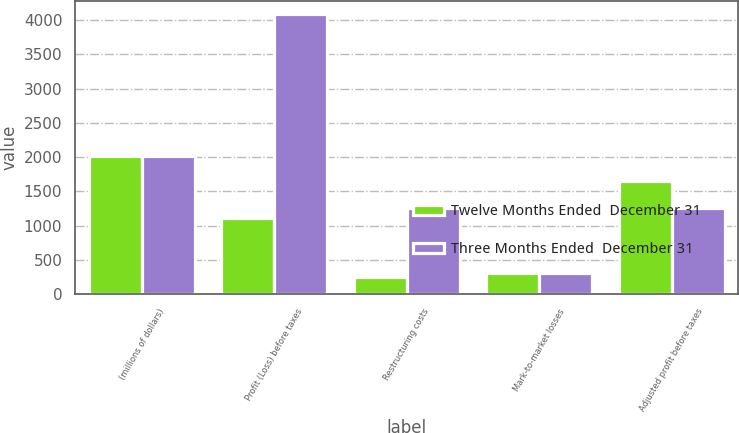Convert chart to OTSL. <chart><loc_0><loc_0><loc_500><loc_500><stacked_bar_chart><ecel><fcel>(millions of dollars)<fcel>Profit (Loss) before taxes<fcel>Restructuring costs<fcel>Mark-to-market losses<fcel>Adjusted profit before taxes<nl><fcel>Twelve Months Ended  December 31<fcel>2017<fcel>1111<fcel>245<fcel>301<fcel>1657<nl><fcel>Three Months Ended  December 31<fcel>2017<fcel>4082<fcel>1256<fcel>301<fcel>1256<nl></chart> 